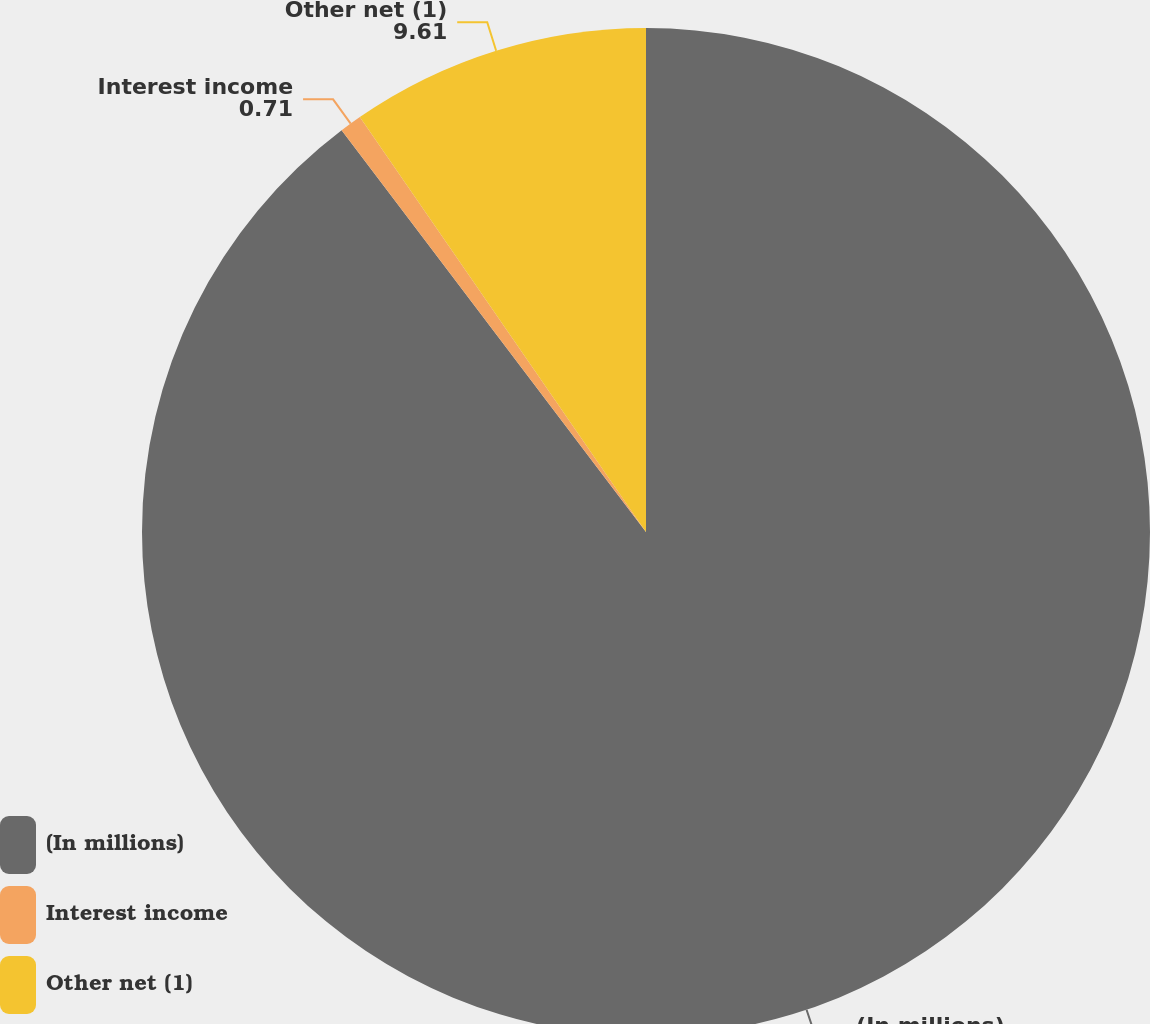Convert chart. <chart><loc_0><loc_0><loc_500><loc_500><pie_chart><fcel>(In millions)<fcel>Interest income<fcel>Other net (1)<nl><fcel>89.68%<fcel>0.71%<fcel>9.61%<nl></chart> 